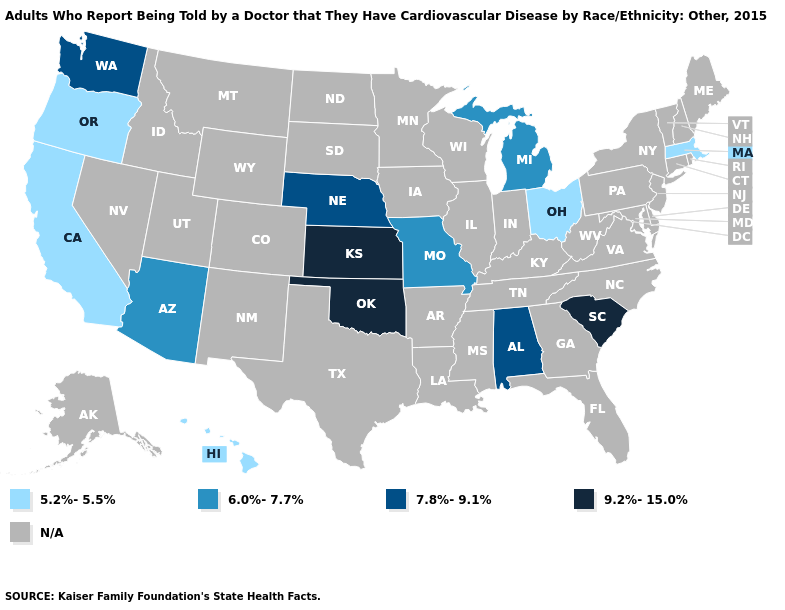Name the states that have a value in the range 5.2%-5.5%?
Concise answer only. California, Hawaii, Massachusetts, Ohio, Oregon. What is the highest value in the USA?
Be succinct. 9.2%-15.0%. Which states have the lowest value in the USA?
Answer briefly. California, Hawaii, Massachusetts, Ohio, Oregon. What is the value of Arizona?
Be succinct. 6.0%-7.7%. Name the states that have a value in the range N/A?
Answer briefly. Alaska, Arkansas, Colorado, Connecticut, Delaware, Florida, Georgia, Idaho, Illinois, Indiana, Iowa, Kentucky, Louisiana, Maine, Maryland, Minnesota, Mississippi, Montana, Nevada, New Hampshire, New Jersey, New Mexico, New York, North Carolina, North Dakota, Pennsylvania, Rhode Island, South Dakota, Tennessee, Texas, Utah, Vermont, Virginia, West Virginia, Wisconsin, Wyoming. Name the states that have a value in the range N/A?
Keep it brief. Alaska, Arkansas, Colorado, Connecticut, Delaware, Florida, Georgia, Idaho, Illinois, Indiana, Iowa, Kentucky, Louisiana, Maine, Maryland, Minnesota, Mississippi, Montana, Nevada, New Hampshire, New Jersey, New Mexico, New York, North Carolina, North Dakota, Pennsylvania, Rhode Island, South Dakota, Tennessee, Texas, Utah, Vermont, Virginia, West Virginia, Wisconsin, Wyoming. What is the value of Louisiana?
Concise answer only. N/A. Which states have the highest value in the USA?
Concise answer only. Kansas, Oklahoma, South Carolina. Does the first symbol in the legend represent the smallest category?
Concise answer only. Yes. What is the highest value in states that border Georgia?
Concise answer only. 9.2%-15.0%. Name the states that have a value in the range N/A?
Be succinct. Alaska, Arkansas, Colorado, Connecticut, Delaware, Florida, Georgia, Idaho, Illinois, Indiana, Iowa, Kentucky, Louisiana, Maine, Maryland, Minnesota, Mississippi, Montana, Nevada, New Hampshire, New Jersey, New Mexico, New York, North Carolina, North Dakota, Pennsylvania, Rhode Island, South Dakota, Tennessee, Texas, Utah, Vermont, Virginia, West Virginia, Wisconsin, Wyoming. Which states hav the highest value in the South?
Short answer required. Oklahoma, South Carolina. 